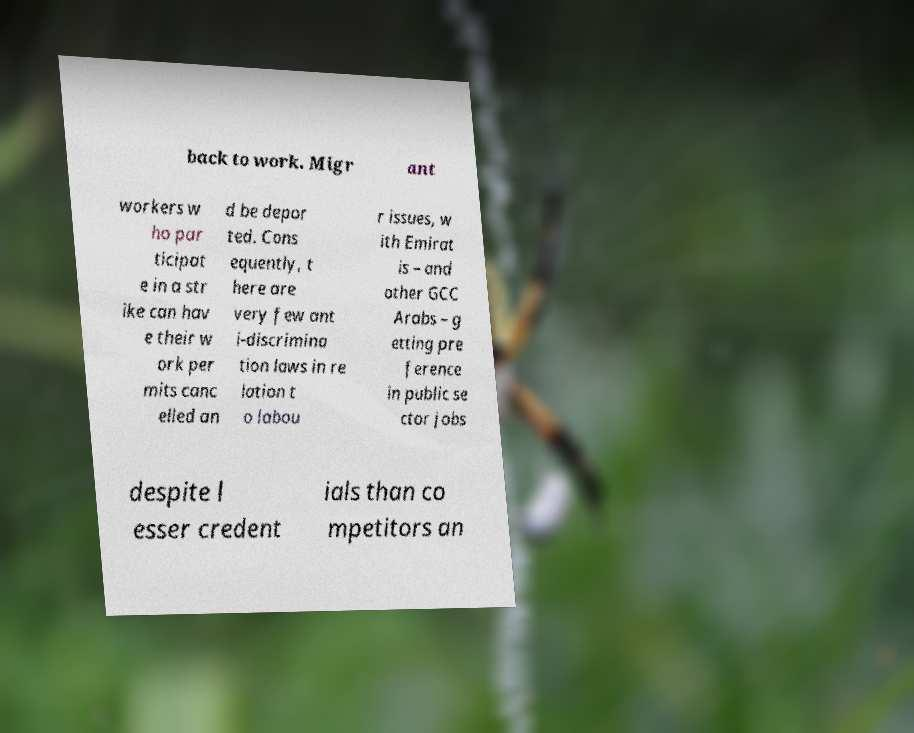For documentation purposes, I need the text within this image transcribed. Could you provide that? back to work. Migr ant workers w ho par ticipat e in a str ike can hav e their w ork per mits canc elled an d be depor ted. Cons equently, t here are very few ant i-discrimina tion laws in re lation t o labou r issues, w ith Emirat is – and other GCC Arabs – g etting pre ference in public se ctor jobs despite l esser credent ials than co mpetitors an 